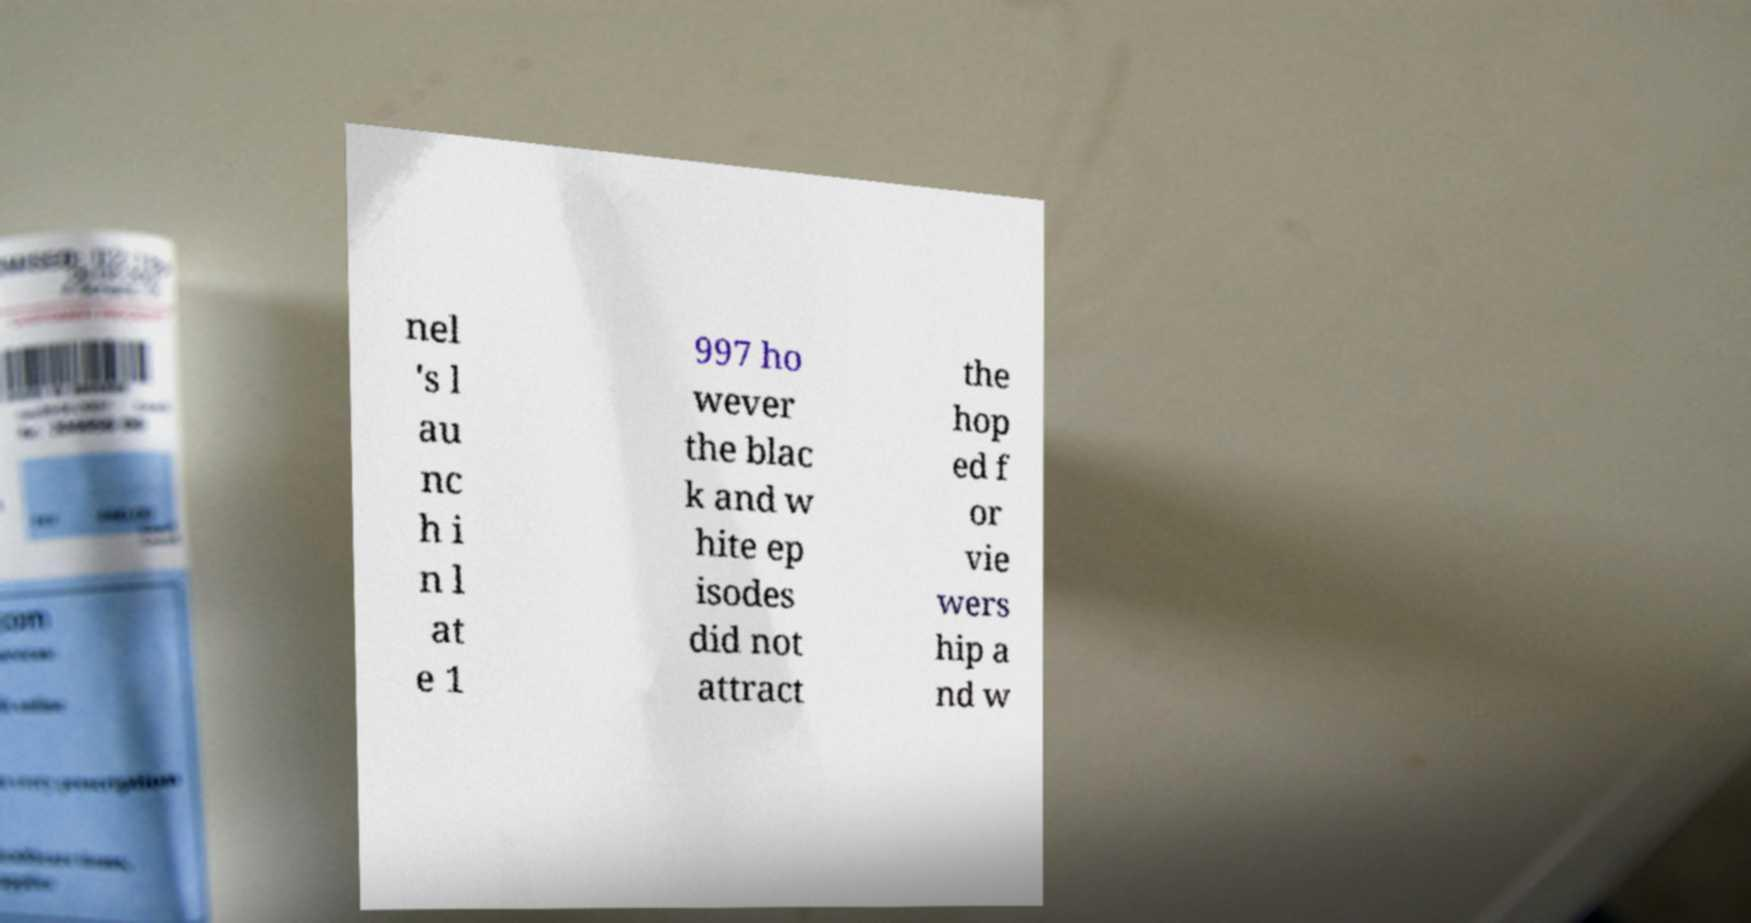I need the written content from this picture converted into text. Can you do that? nel 's l au nc h i n l at e 1 997 ho wever the blac k and w hite ep isodes did not attract the hop ed f or vie wers hip a nd w 